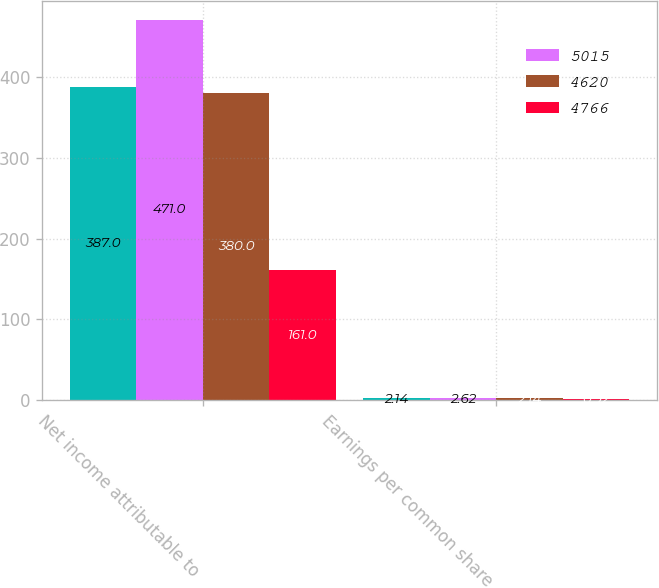Convert chart. <chart><loc_0><loc_0><loc_500><loc_500><stacked_bar_chart><ecel><fcel>Net income attributable to<fcel>Earnings per common share<nl><fcel>nan<fcel>387<fcel>2.14<nl><fcel>5015<fcel>471<fcel>2.62<nl><fcel>4620<fcel>380<fcel>2.14<nl><fcel>4766<fcel>161<fcel>0.92<nl></chart> 